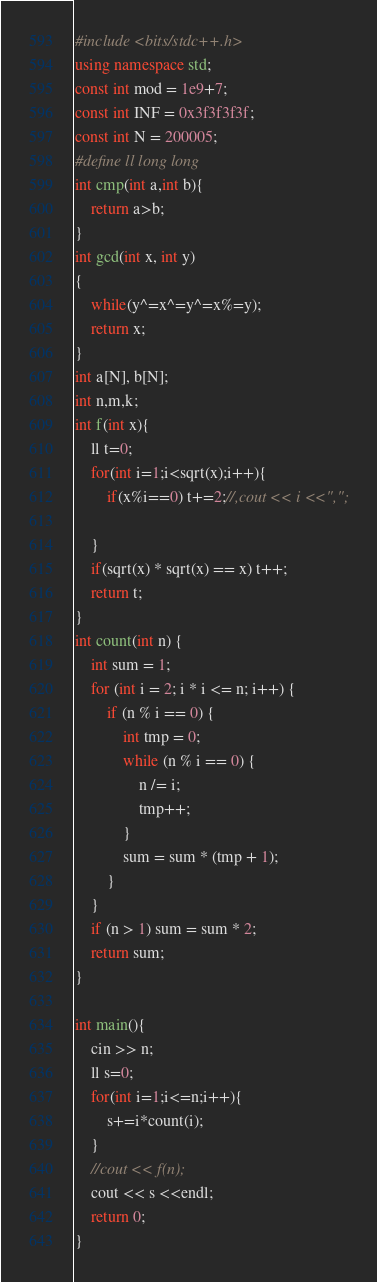<code> <loc_0><loc_0><loc_500><loc_500><_C++_>#include <bits/stdc++.h>
using namespace std;
const int mod = 1e9+7;
const int INF = 0x3f3f3f3f;
const int N = 200005;
#define ll long long
int cmp(int a,int b){
	return a>b;
}	
int gcd(int x, int y)
{
    while(y^=x^=y^=x%=y);
    return x;
}
int a[N], b[N];
int n,m,k;
int f(int x){
	ll t=0;
	for(int i=1;i<sqrt(x);i++){
		if(x%i==0) t+=2;//,cout << i <<",";
		
	}
	if(sqrt(x) * sqrt(x) == x) t++;
	return t;
}
int count(int n) {
    int sum = 1;
    for (int i = 2; i * i <= n; i++) {
        if (n % i == 0) {
            int tmp = 0;
            while (n % i == 0) {
                n /= i;
                tmp++;
            }
            sum = sum * (tmp + 1);
        }
    }
    if (n > 1) sum = sum * 2;
    return sum;
}

int main(){		
	cin >> n;
	ll s=0;
	for(int i=1;i<=n;i++){
		s+=i*count(i);
	}
	//cout << f(n);
	cout << s <<endl;
	return 0;
}


</code> 